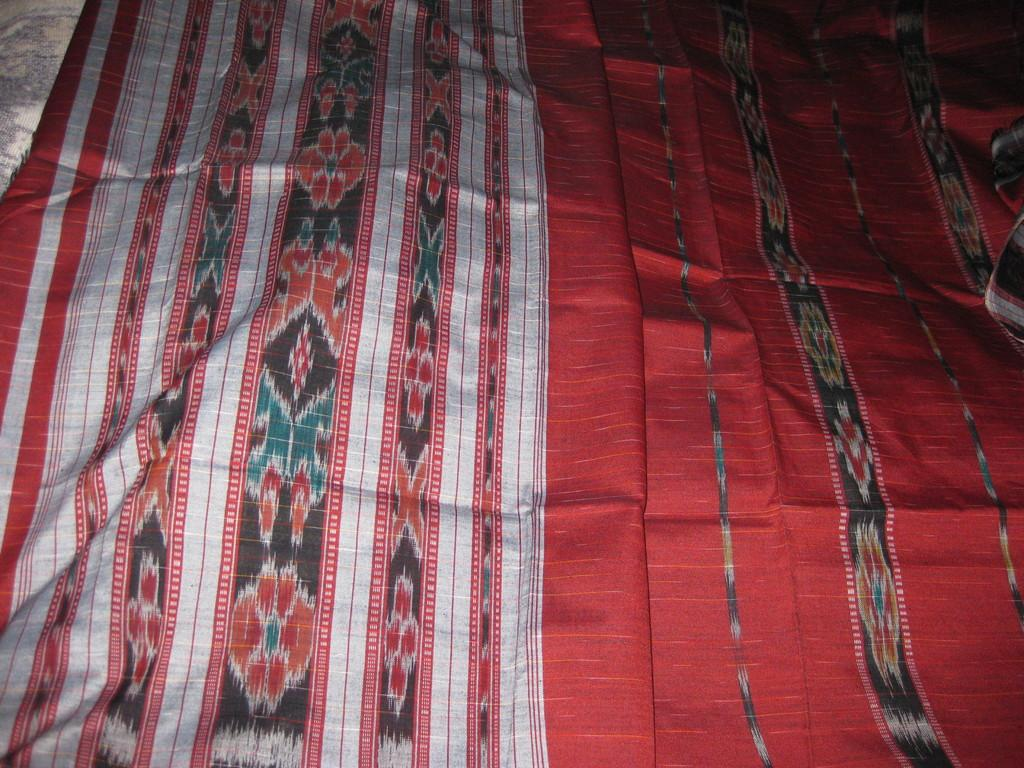What type of clothing is featured in the picture? There is a saree in the picture. Can you describe the colors of the saree? The saree has red, black, grey, orange, and blue colors. How many toes are visible on the person wearing the saree in the image? There is no person visible in the image, so it is impossible to determine the number of toes. 